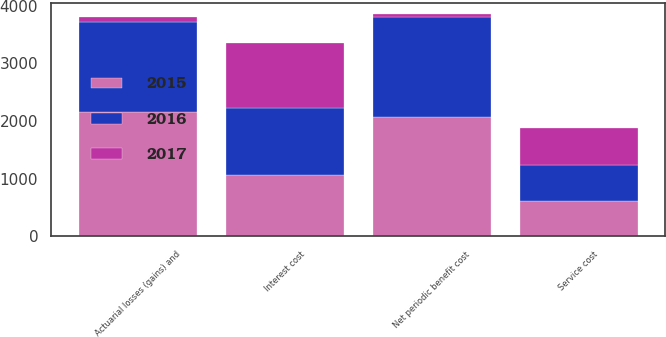Convert chart to OTSL. <chart><loc_0><loc_0><loc_500><loc_500><stacked_bar_chart><ecel><fcel>Service cost<fcel>Interest cost<fcel>Actuarial losses (gains) and<fcel>Net periodic benefit cost<nl><fcel>2017<fcel>638<fcel>1128<fcel>95<fcel>52<nl><fcel>2016<fcel>622<fcel>1155<fcel>1563<fcel>1732<nl><fcel>2015<fcel>615<fcel>1068<fcel>2154<fcel>2070<nl></chart> 